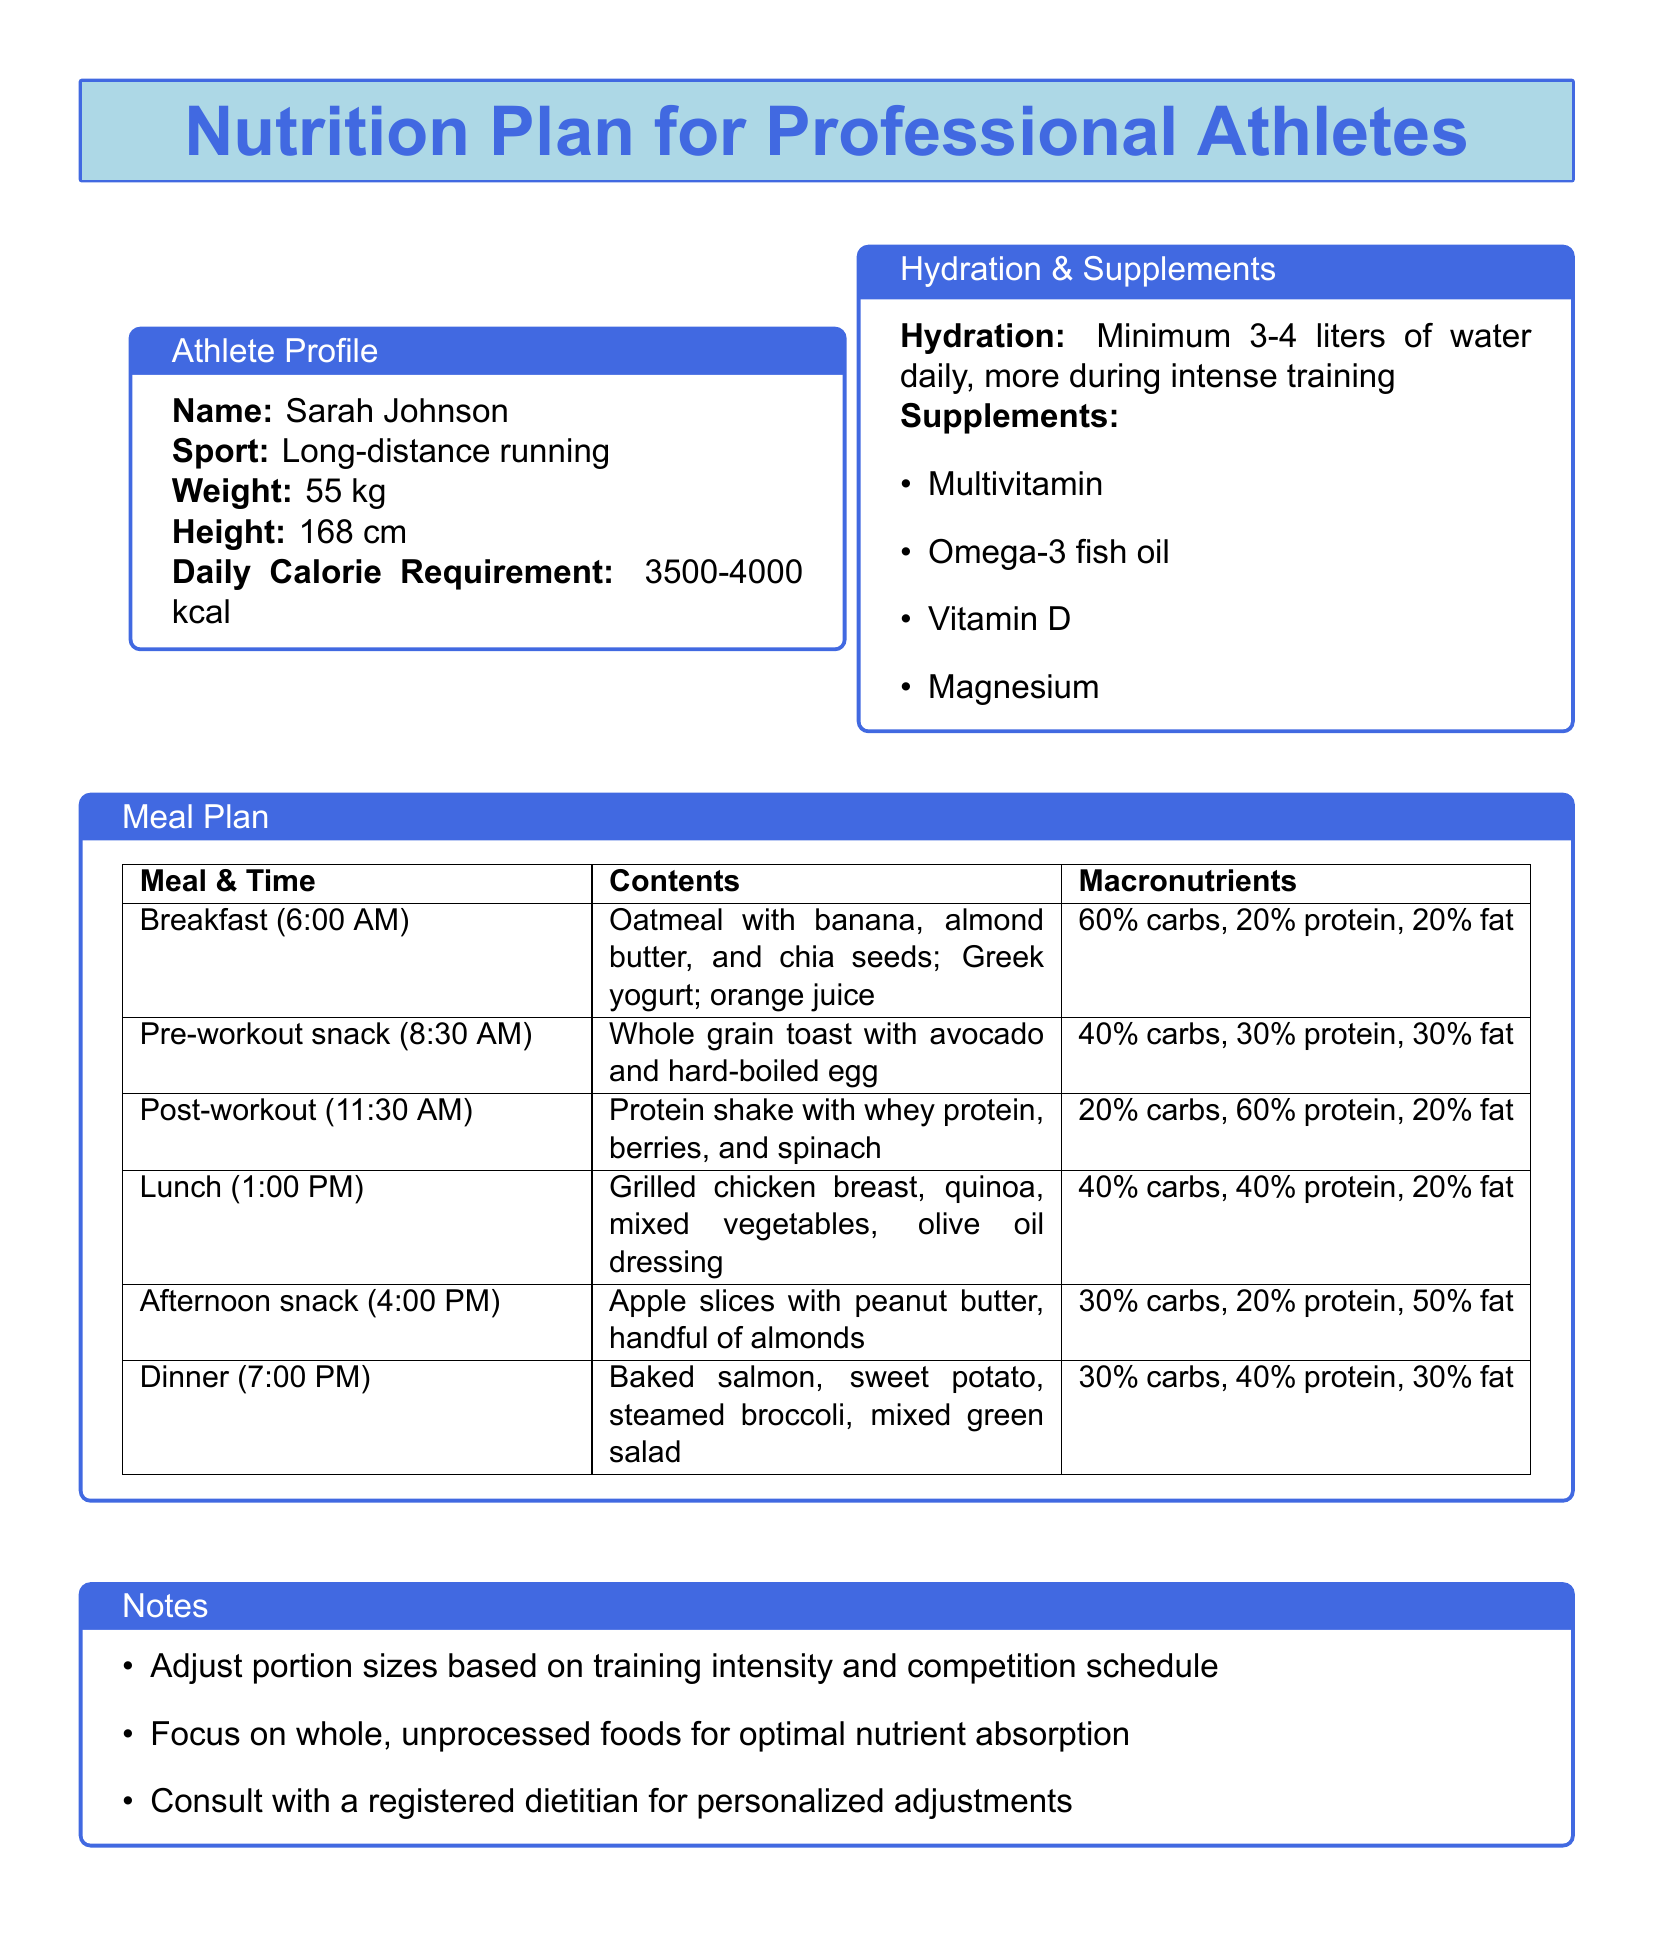What is the name of the athlete? The document states that the athlete's name is Sarah Johnson.
Answer: Sarah Johnson What sport does the athlete participate in? The document specifies that Sarah Johnson participates in long-distance running.
Answer: Long-distance running What is the daily calorie requirement for the athlete? The document mentions that the athlete requires between 3500-4000 kcal daily.
Answer: 3500-4000 kcal What time is breakfast scheduled? According to the meal plan in the document, breakfast is at 6:00 AM.
Answer: 6:00 AM What is the macronutrient breakdown of the lunch meal? The meal plan states that lunch consists of 40% carbs, 40% protein, and 20% fat.
Answer: 40% carbs, 40% protein, 20% fat How much water should the athlete drink daily? The document indicates a hydration goal of a minimum of 3-4 liters of water daily.
Answer: 3-4 liters What should the athlete focus on for optimal nutrient absorption? The document advises focusing on whole, unprocessed foods for optimal nutrient absorption.
Answer: Whole, unprocessed foods What supplement is mentioned for heart health? The document lists omega-3 fish oil as a supplement for heart health.
Answer: Omega-3 fish oil What is suggested for portion size adjustments? The document suggests adjusting portion sizes based on training intensity and competition schedule.
Answer: Training intensity and competition schedule 